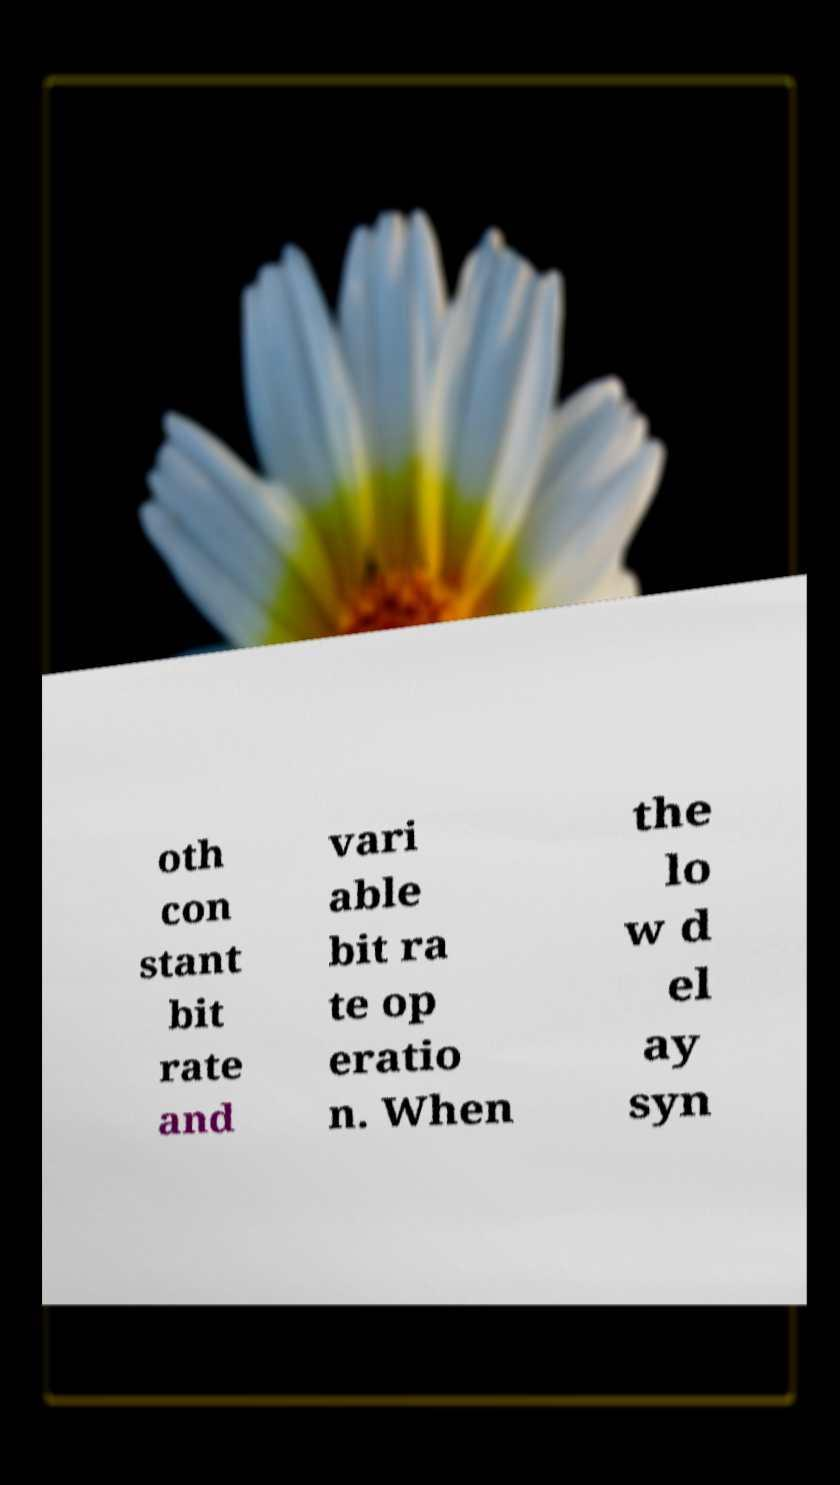Please identify and transcribe the text found in this image. oth con stant bit rate and vari able bit ra te op eratio n. When the lo w d el ay syn 